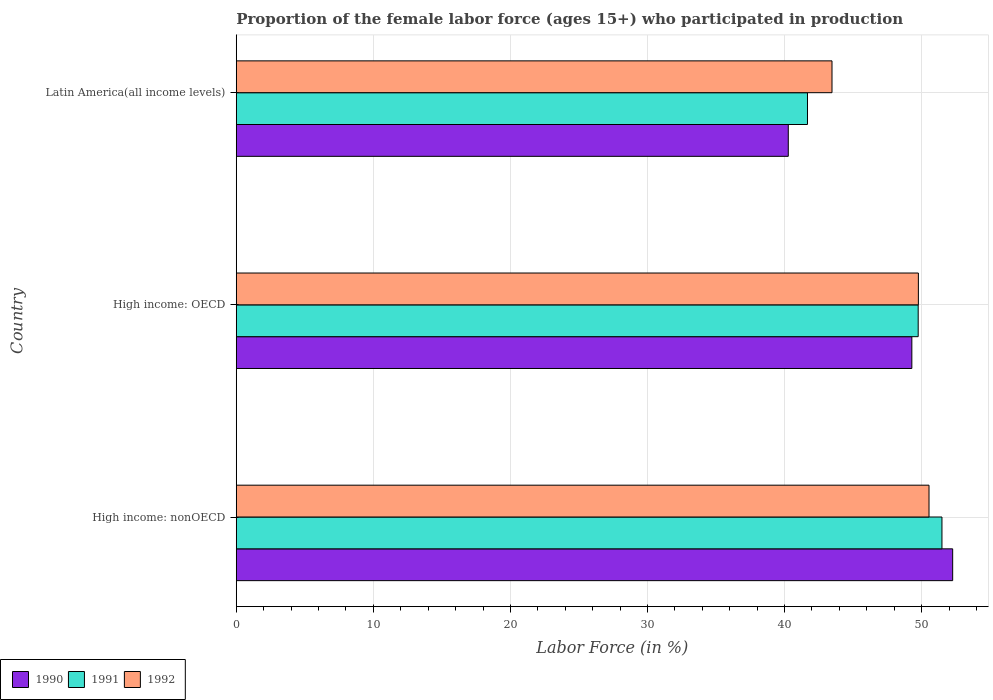How many different coloured bars are there?
Ensure brevity in your answer.  3. Are the number of bars per tick equal to the number of legend labels?
Your answer should be compact. Yes. What is the label of the 3rd group of bars from the top?
Provide a short and direct response. High income: nonOECD. In how many cases, is the number of bars for a given country not equal to the number of legend labels?
Your answer should be very brief. 0. What is the proportion of the female labor force who participated in production in 1991 in High income: nonOECD?
Ensure brevity in your answer.  51.48. Across all countries, what is the maximum proportion of the female labor force who participated in production in 1991?
Keep it short and to the point. 51.48. Across all countries, what is the minimum proportion of the female labor force who participated in production in 1992?
Your answer should be compact. 43.46. In which country was the proportion of the female labor force who participated in production in 1990 maximum?
Keep it short and to the point. High income: nonOECD. In which country was the proportion of the female labor force who participated in production in 1990 minimum?
Make the answer very short. Latin America(all income levels). What is the total proportion of the female labor force who participated in production in 1991 in the graph?
Provide a short and direct response. 142.9. What is the difference between the proportion of the female labor force who participated in production in 1992 in High income: OECD and that in Latin America(all income levels)?
Ensure brevity in your answer.  6.3. What is the difference between the proportion of the female labor force who participated in production in 1991 in Latin America(all income levels) and the proportion of the female labor force who participated in production in 1990 in High income: nonOECD?
Offer a very short reply. -10.59. What is the average proportion of the female labor force who participated in production in 1990 per country?
Offer a very short reply. 47.27. What is the difference between the proportion of the female labor force who participated in production in 1990 and proportion of the female labor force who participated in production in 1992 in High income: nonOECD?
Your answer should be compact. 1.73. In how many countries, is the proportion of the female labor force who participated in production in 1990 greater than 28 %?
Your answer should be compact. 3. What is the ratio of the proportion of the female labor force who participated in production in 1991 in High income: OECD to that in High income: nonOECD?
Ensure brevity in your answer.  0.97. Is the proportion of the female labor force who participated in production in 1992 in High income: OECD less than that in High income: nonOECD?
Your answer should be very brief. Yes. What is the difference between the highest and the second highest proportion of the female labor force who participated in production in 1990?
Make the answer very short. 2.98. What is the difference between the highest and the lowest proportion of the female labor force who participated in production in 1992?
Give a very brief answer. 7.08. In how many countries, is the proportion of the female labor force who participated in production in 1990 greater than the average proportion of the female labor force who participated in production in 1990 taken over all countries?
Provide a short and direct response. 2. What does the 2nd bar from the bottom in High income: nonOECD represents?
Your answer should be very brief. 1991. Are all the bars in the graph horizontal?
Your answer should be compact. Yes. How many countries are there in the graph?
Your answer should be compact. 3. Are the values on the major ticks of X-axis written in scientific E-notation?
Give a very brief answer. No. Does the graph contain any zero values?
Offer a very short reply. No. Where does the legend appear in the graph?
Provide a succinct answer. Bottom left. How many legend labels are there?
Offer a terse response. 3. What is the title of the graph?
Keep it short and to the point. Proportion of the female labor force (ages 15+) who participated in production. What is the label or title of the Y-axis?
Your answer should be compact. Country. What is the Labor Force (in %) in 1990 in High income: nonOECD?
Give a very brief answer. 52.26. What is the Labor Force (in %) in 1991 in High income: nonOECD?
Ensure brevity in your answer.  51.48. What is the Labor Force (in %) of 1992 in High income: nonOECD?
Provide a short and direct response. 50.54. What is the Labor Force (in %) of 1990 in High income: OECD?
Provide a succinct answer. 49.29. What is the Labor Force (in %) of 1991 in High income: OECD?
Your response must be concise. 49.75. What is the Labor Force (in %) in 1992 in High income: OECD?
Your answer should be compact. 49.76. What is the Labor Force (in %) of 1990 in Latin America(all income levels)?
Your response must be concise. 40.27. What is the Labor Force (in %) of 1991 in Latin America(all income levels)?
Ensure brevity in your answer.  41.67. What is the Labor Force (in %) in 1992 in Latin America(all income levels)?
Make the answer very short. 43.46. Across all countries, what is the maximum Labor Force (in %) of 1990?
Your answer should be very brief. 52.26. Across all countries, what is the maximum Labor Force (in %) in 1991?
Keep it short and to the point. 51.48. Across all countries, what is the maximum Labor Force (in %) in 1992?
Provide a short and direct response. 50.54. Across all countries, what is the minimum Labor Force (in %) of 1990?
Keep it short and to the point. 40.27. Across all countries, what is the minimum Labor Force (in %) in 1991?
Your answer should be very brief. 41.67. Across all countries, what is the minimum Labor Force (in %) of 1992?
Make the answer very short. 43.46. What is the total Labor Force (in %) in 1990 in the graph?
Offer a very short reply. 141.82. What is the total Labor Force (in %) of 1991 in the graph?
Ensure brevity in your answer.  142.9. What is the total Labor Force (in %) in 1992 in the graph?
Make the answer very short. 143.76. What is the difference between the Labor Force (in %) of 1990 in High income: nonOECD and that in High income: OECD?
Offer a terse response. 2.98. What is the difference between the Labor Force (in %) of 1991 in High income: nonOECD and that in High income: OECD?
Offer a terse response. 1.73. What is the difference between the Labor Force (in %) in 1992 in High income: nonOECD and that in High income: OECD?
Make the answer very short. 0.78. What is the difference between the Labor Force (in %) of 1990 in High income: nonOECD and that in Latin America(all income levels)?
Keep it short and to the point. 11.99. What is the difference between the Labor Force (in %) of 1991 in High income: nonOECD and that in Latin America(all income levels)?
Provide a succinct answer. 9.81. What is the difference between the Labor Force (in %) in 1992 in High income: nonOECD and that in Latin America(all income levels)?
Give a very brief answer. 7.08. What is the difference between the Labor Force (in %) in 1990 in High income: OECD and that in Latin America(all income levels)?
Offer a terse response. 9.01. What is the difference between the Labor Force (in %) of 1991 in High income: OECD and that in Latin America(all income levels)?
Provide a succinct answer. 8.08. What is the difference between the Labor Force (in %) in 1992 in High income: OECD and that in Latin America(all income levels)?
Make the answer very short. 6.3. What is the difference between the Labor Force (in %) of 1990 in High income: nonOECD and the Labor Force (in %) of 1991 in High income: OECD?
Make the answer very short. 2.52. What is the difference between the Labor Force (in %) in 1990 in High income: nonOECD and the Labor Force (in %) in 1992 in High income: OECD?
Your response must be concise. 2.5. What is the difference between the Labor Force (in %) of 1991 in High income: nonOECD and the Labor Force (in %) of 1992 in High income: OECD?
Give a very brief answer. 1.72. What is the difference between the Labor Force (in %) in 1990 in High income: nonOECD and the Labor Force (in %) in 1991 in Latin America(all income levels)?
Ensure brevity in your answer.  10.59. What is the difference between the Labor Force (in %) of 1990 in High income: nonOECD and the Labor Force (in %) of 1992 in Latin America(all income levels)?
Your response must be concise. 8.8. What is the difference between the Labor Force (in %) of 1991 in High income: nonOECD and the Labor Force (in %) of 1992 in Latin America(all income levels)?
Give a very brief answer. 8.02. What is the difference between the Labor Force (in %) of 1990 in High income: OECD and the Labor Force (in %) of 1991 in Latin America(all income levels)?
Offer a terse response. 7.61. What is the difference between the Labor Force (in %) of 1990 in High income: OECD and the Labor Force (in %) of 1992 in Latin America(all income levels)?
Your answer should be very brief. 5.82. What is the difference between the Labor Force (in %) in 1991 in High income: OECD and the Labor Force (in %) in 1992 in Latin America(all income levels)?
Your response must be concise. 6.29. What is the average Labor Force (in %) of 1990 per country?
Provide a succinct answer. 47.27. What is the average Labor Force (in %) of 1991 per country?
Your response must be concise. 47.63. What is the average Labor Force (in %) of 1992 per country?
Ensure brevity in your answer.  47.92. What is the difference between the Labor Force (in %) in 1990 and Labor Force (in %) in 1991 in High income: nonOECD?
Provide a succinct answer. 0.78. What is the difference between the Labor Force (in %) of 1990 and Labor Force (in %) of 1992 in High income: nonOECD?
Keep it short and to the point. 1.73. What is the difference between the Labor Force (in %) of 1991 and Labor Force (in %) of 1992 in High income: nonOECD?
Provide a short and direct response. 0.94. What is the difference between the Labor Force (in %) in 1990 and Labor Force (in %) in 1991 in High income: OECD?
Offer a very short reply. -0.46. What is the difference between the Labor Force (in %) in 1990 and Labor Force (in %) in 1992 in High income: OECD?
Provide a short and direct response. -0.48. What is the difference between the Labor Force (in %) in 1991 and Labor Force (in %) in 1992 in High income: OECD?
Your response must be concise. -0.01. What is the difference between the Labor Force (in %) of 1990 and Labor Force (in %) of 1991 in Latin America(all income levels)?
Ensure brevity in your answer.  -1.4. What is the difference between the Labor Force (in %) in 1990 and Labor Force (in %) in 1992 in Latin America(all income levels)?
Your answer should be compact. -3.19. What is the difference between the Labor Force (in %) in 1991 and Labor Force (in %) in 1992 in Latin America(all income levels)?
Your answer should be compact. -1.79. What is the ratio of the Labor Force (in %) of 1990 in High income: nonOECD to that in High income: OECD?
Make the answer very short. 1.06. What is the ratio of the Labor Force (in %) in 1991 in High income: nonOECD to that in High income: OECD?
Your answer should be compact. 1.03. What is the ratio of the Labor Force (in %) in 1992 in High income: nonOECD to that in High income: OECD?
Keep it short and to the point. 1.02. What is the ratio of the Labor Force (in %) of 1990 in High income: nonOECD to that in Latin America(all income levels)?
Make the answer very short. 1.3. What is the ratio of the Labor Force (in %) in 1991 in High income: nonOECD to that in Latin America(all income levels)?
Your response must be concise. 1.24. What is the ratio of the Labor Force (in %) in 1992 in High income: nonOECD to that in Latin America(all income levels)?
Ensure brevity in your answer.  1.16. What is the ratio of the Labor Force (in %) of 1990 in High income: OECD to that in Latin America(all income levels)?
Keep it short and to the point. 1.22. What is the ratio of the Labor Force (in %) of 1991 in High income: OECD to that in Latin America(all income levels)?
Your answer should be very brief. 1.19. What is the ratio of the Labor Force (in %) in 1992 in High income: OECD to that in Latin America(all income levels)?
Your response must be concise. 1.15. What is the difference between the highest and the second highest Labor Force (in %) of 1990?
Your answer should be compact. 2.98. What is the difference between the highest and the second highest Labor Force (in %) of 1991?
Give a very brief answer. 1.73. What is the difference between the highest and the second highest Labor Force (in %) in 1992?
Provide a succinct answer. 0.78. What is the difference between the highest and the lowest Labor Force (in %) of 1990?
Provide a succinct answer. 11.99. What is the difference between the highest and the lowest Labor Force (in %) of 1991?
Ensure brevity in your answer.  9.81. What is the difference between the highest and the lowest Labor Force (in %) in 1992?
Provide a succinct answer. 7.08. 